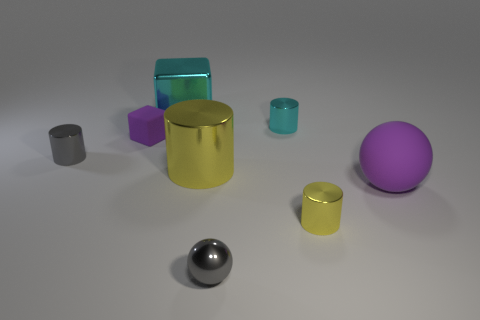Which object stands out the most to you and why? The large yellow cylinder stands out the most due to its size and its vibrant color that contrasts sharply with the more subdued hues and smaller sizes of the surrounding objects. Can the texture of the objects be described? Certainly! The small grey cylinder and the purple matte sphere have a dull, non-reflective surface. The blue and teal cylinders are translucent with a slightly shiny surface. The violet cube looks slightly less shiny than the purple sphere. The large yellow cylinder has a glossy finish, and the metallic sphere has a highly reflective surface. 